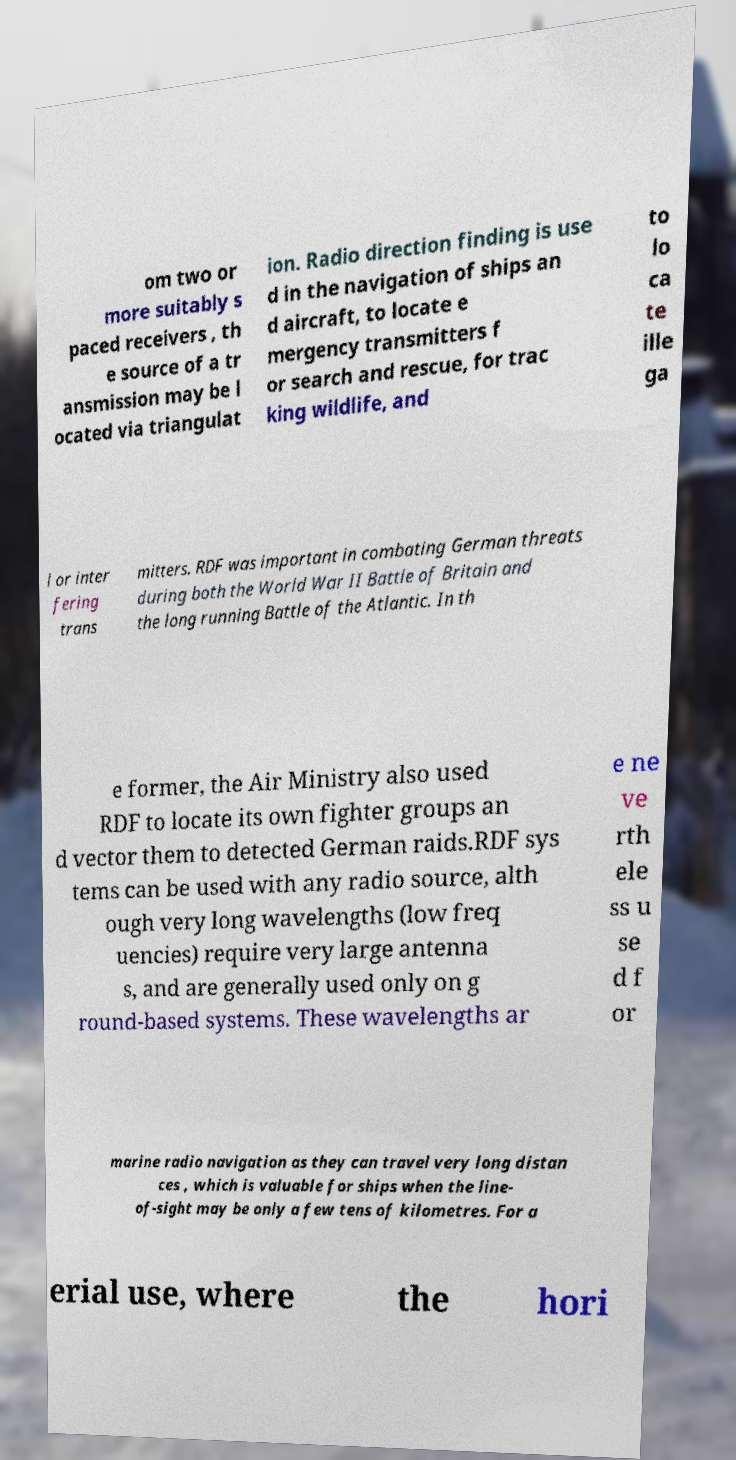For documentation purposes, I need the text within this image transcribed. Could you provide that? om two or more suitably s paced receivers , th e source of a tr ansmission may be l ocated via triangulat ion. Radio direction finding is use d in the navigation of ships an d aircraft, to locate e mergency transmitters f or search and rescue, for trac king wildlife, and to lo ca te ille ga l or inter fering trans mitters. RDF was important in combating German threats during both the World War II Battle of Britain and the long running Battle of the Atlantic. In th e former, the Air Ministry also used RDF to locate its own fighter groups an d vector them to detected German raids.RDF sys tems can be used with any radio source, alth ough very long wavelengths (low freq uencies) require very large antenna s, and are generally used only on g round-based systems. These wavelengths ar e ne ve rth ele ss u se d f or marine radio navigation as they can travel very long distan ces , which is valuable for ships when the line- of-sight may be only a few tens of kilometres. For a erial use, where the hori 